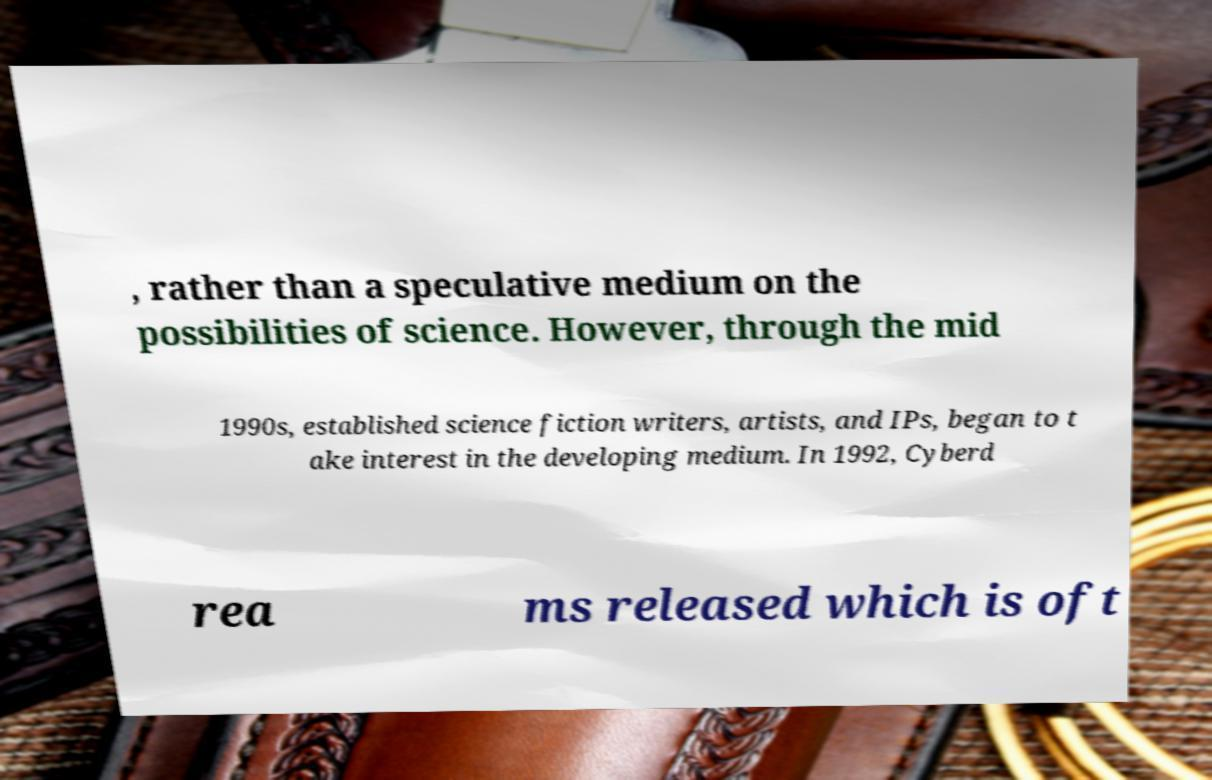For documentation purposes, I need the text within this image transcribed. Could you provide that? , rather than a speculative medium on the possibilities of science. However, through the mid 1990s, established science fiction writers, artists, and IPs, began to t ake interest in the developing medium. In 1992, Cyberd rea ms released which is oft 